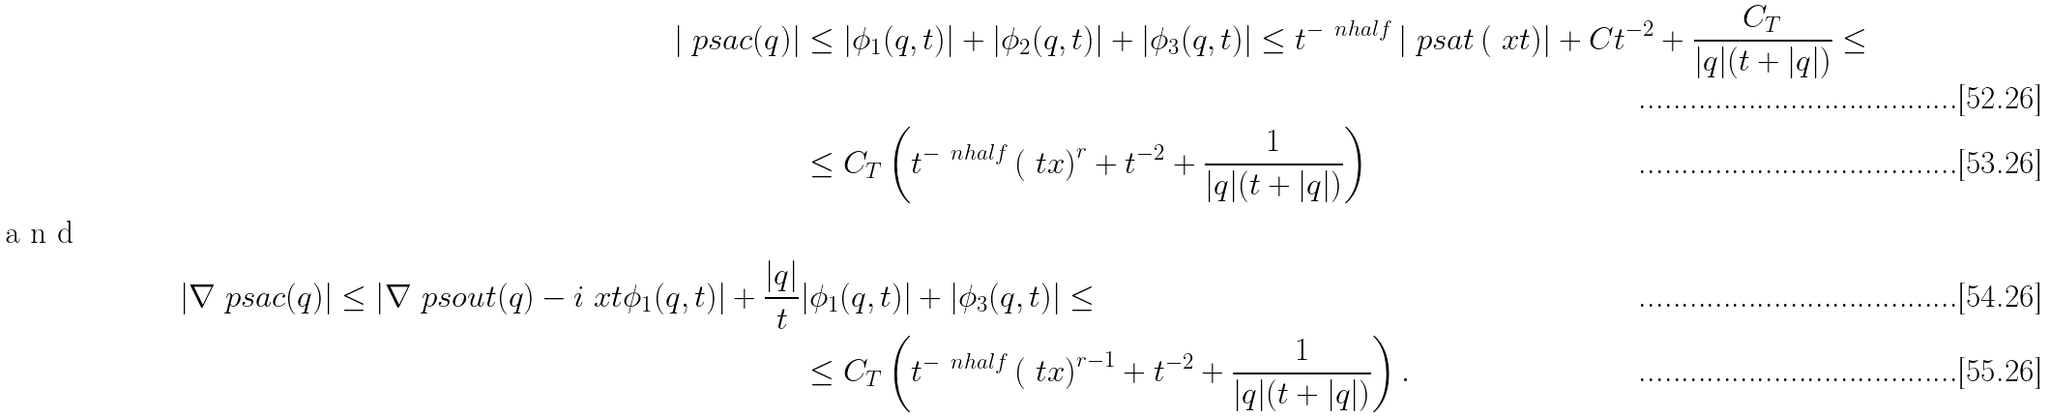<formula> <loc_0><loc_0><loc_500><loc_500>| \ p s a c ( q ) | & \leq | \phi _ { 1 } ( q , t ) | + | \phi _ { 2 } ( q , t ) | + | \phi _ { 3 } ( q , t ) | \leq t ^ { - \ n h a l f } \left | \ p s a t \left ( \ x t \right ) \right | + C t ^ { - 2 } + \frac { C _ { T } } { | q | ( t + | q | ) } \leq \\ & \leq C _ { T } \left ( t ^ { - \ n h a l f } \left ( \ t x \right ) ^ { r } + t ^ { - 2 } + \frac { 1 } { | q | ( t + | q | ) } \right ) \\ \intertext { a n d } | \nabla \ p s a c ( q ) | \leq \left | \nabla \ p s o u t ( q ) - i \ x t \phi _ { 1 } ( q , t ) \right | + \frac { | q | } { t } & | \phi _ { 1 } ( q , t ) | + | \phi _ { 3 } ( q , t ) | \leq \\ & \leq C _ { T } \left ( t ^ { - \ n h a l f } \left ( \ t x \right ) ^ { r - 1 } + t ^ { - 2 } + \frac { 1 } { | q | ( t + | q | ) } \right ) .</formula> 